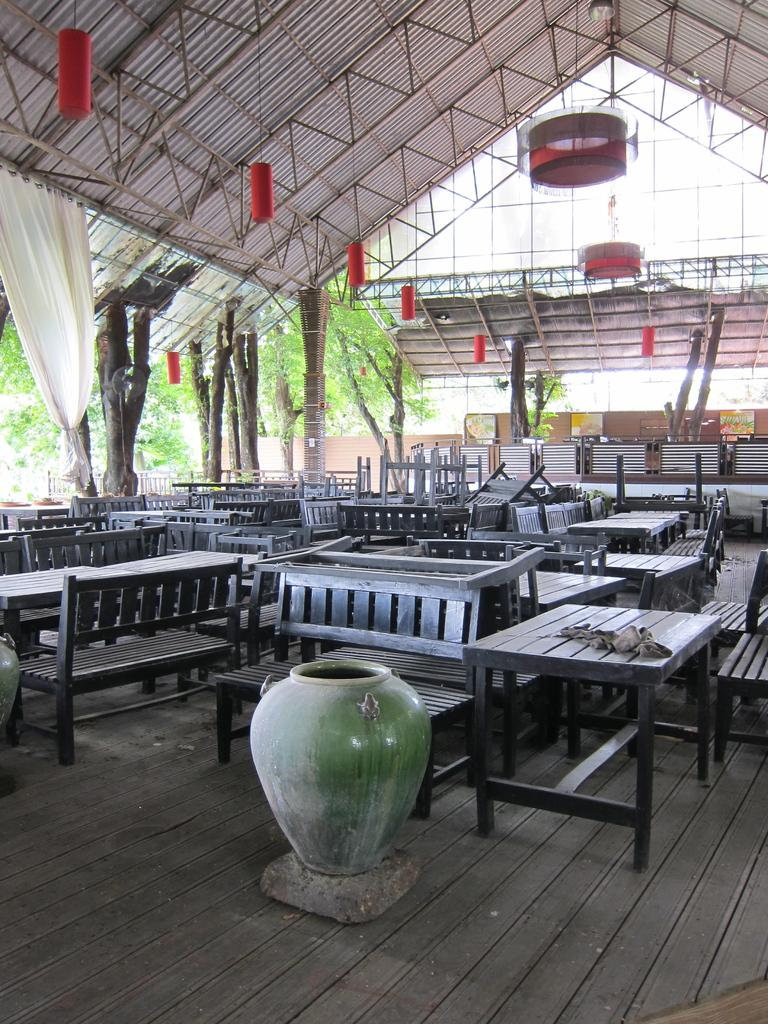What is the main object in the center of the image? There is a pot in the center of the image. What type of furniture is visible behind the pot? Tables and benches are visible behind the pot. Where are the tables and benches located? The tables and benches are under a shed. What can be seen in the background of the image? There are trees in the background of the image. What type of coil is used to power the shed in the image? There is no coil or shed depicted in the image; it only shows a pot, tables, benches, and trees. Can you tell me how many trains are passing by in the image? There are no trains present in the image. 